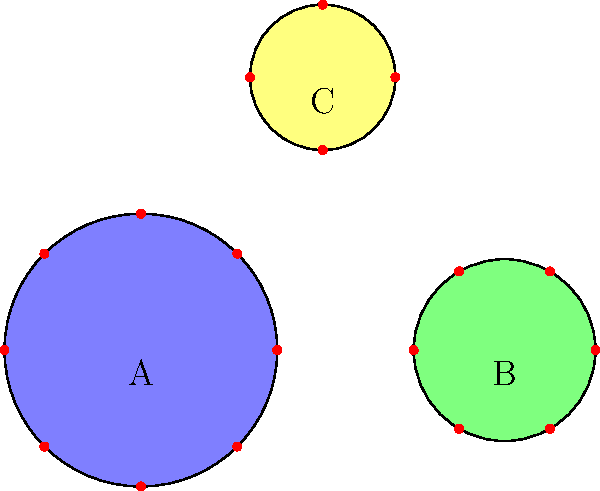As the organizer of a charitable dinner event, you need to determine the most efficient seating arrangement. The diagram shows three table options: Table A (blue, seats 8), Table B (green, seats 6), and Table C (yellow, seats 4). If you need to accommodate 36 guests while minimizing the number of tables used, which combination of tables should you choose? To find the most efficient seating arrangement, we need to determine the combination of tables that can seat 36 guests using the least number of tables. Let's approach this step-by-step:

1. First, let's list the seating capacity of each table:
   Table A: 8 seats
   Table B: 6 seats
   Table C: 4 seats

2. We need to find a combination that adds up to 36 seats. Let's start with the largest table and work our way down:

3. Using only Table A:
   $36 \div 8 = 4.5$
   We would need 5 of Table A, but this would give us 40 seats, which is too many.

4. Let's try a combination of Table A and Table B:
   $4 \times 8 = 32$ (four Table A)
   $36 - 32 = 4$ seats remaining
   We can't use Table B for the remaining 4 seats as it has 6 seats.

5. The most efficient combination:
   $4 \times 8 = 32$ (four Table A)
   $1 \times 4 = 4$ (one Table C)
   $32 + 4 = 36$ seats total

6. This combination uses 5 tables in total (4 of Table A and 1 of Table C), which is the minimum number of tables needed to seat exactly 36 guests.
Answer: 4 Table A + 1 Table C 